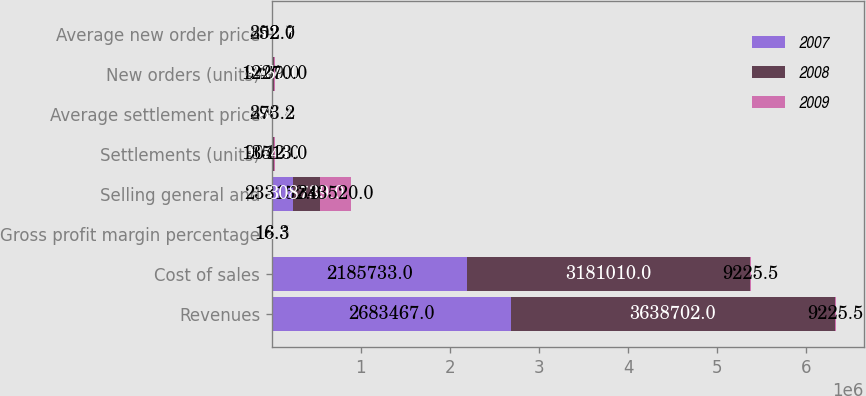Convert chart. <chart><loc_0><loc_0><loc_500><loc_500><stacked_bar_chart><ecel><fcel>Revenues<fcel>Cost of sales<fcel>Gross profit margin percentage<fcel>Selling general and<fcel>Settlements (units)<fcel>Average settlement price<fcel>New orders (units)<fcel>Average new order price<nl><fcel>2007<fcel>2.68347e+06<fcel>2.18573e+06<fcel>18.5<fcel>233152<fcel>9042<fcel>296.4<fcel>9409<fcel>292.7<nl><fcel>2008<fcel>3.6387e+06<fcel>3.18101e+06<fcel>12.6<fcel>308739<fcel>10741<fcel>338.4<fcel>8760<fcel>311.3<nl><fcel>2009<fcel>9225.5<fcel>9225.5<fcel>16.3<fcel>343520<fcel>13513<fcel>373.2<fcel>12270<fcel>352<nl></chart> 